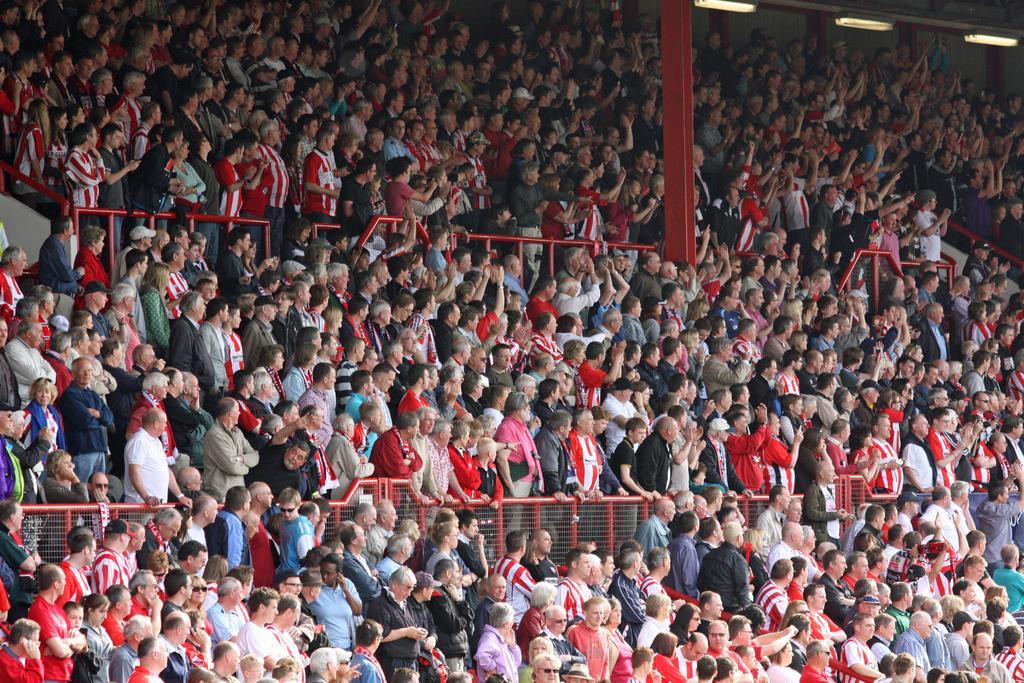Could you give a brief overview of what you see in this image? In this picture, there is a stadium filled with the people. On the top right, there is a pillar. In between the people, there are fences. 